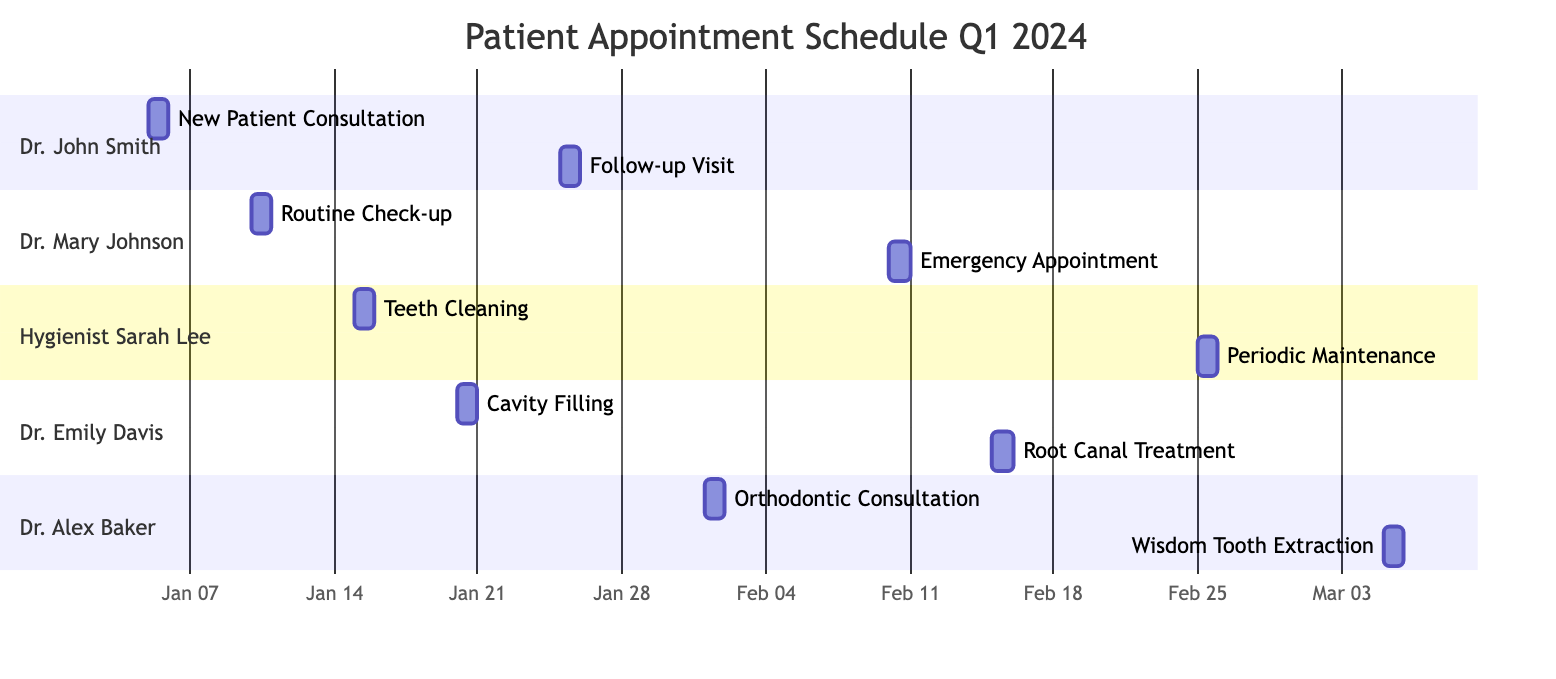What is the duration of a Routine Check-up? The diagram shows that the Routine Check-up appointment has a duration of 30 minutes. This is explicitly stated in the data for that particular appointment.
Answer: 30 minutes Who is assigned to the Wisdom Tooth Extraction? Based on the section for Dr. Alex Baker in the diagram, the assignment for the Wisdom Tooth Extraction is clearly listed under his name.
Answer: Dr. Alex Baker How many appointments are scheduled for Dr. Emily Davis in Q1 2024? Reviewing Dr. Emily Davis's section in the diagram, there are two appointments: Cavity Filling and Root Canal Treatment. This brings the total to two.
Answer: 2 What type of appointment is scheduled on January 10? The diagram specifies that on January 10, the appointment is a Routine Check-up. This can be directly inferred from the listing under Dr. Mary Johnson's section.
Answer: Routine Check-up Which staff member has a Follow-up Visit on January 25? The Follow-up Visit is specifically assigned to Dr. John Smith, as indicated in the diagram under his section.
Answer: Dr. John Smith What is the last appointment scheduled in the diagram? The last appointment indicated in the timeline is the Wisdom Tooth Extraction, scheduled for March 5, 2024, as found in Dr. Alex Baker's section.
Answer: Wisdom Tooth Extraction What is the total duration of appointments scheduled for Hygienist Sarah Lee? Hygienist Sarah Lee has two appointments: Teeth Cleaning (45 minutes) and Periodic Maintenance (45 minutes). Adding these gives a total of 90 minutes.
Answer: 90 minutes Which appointment type takes the longest time? Reviewing the appointment durations in the diagram, the Root Canal Treatment has the longest duration of 90 minutes. This can be concluded by comparing all other appointment durations.
Answer: Root Canal Treatment 